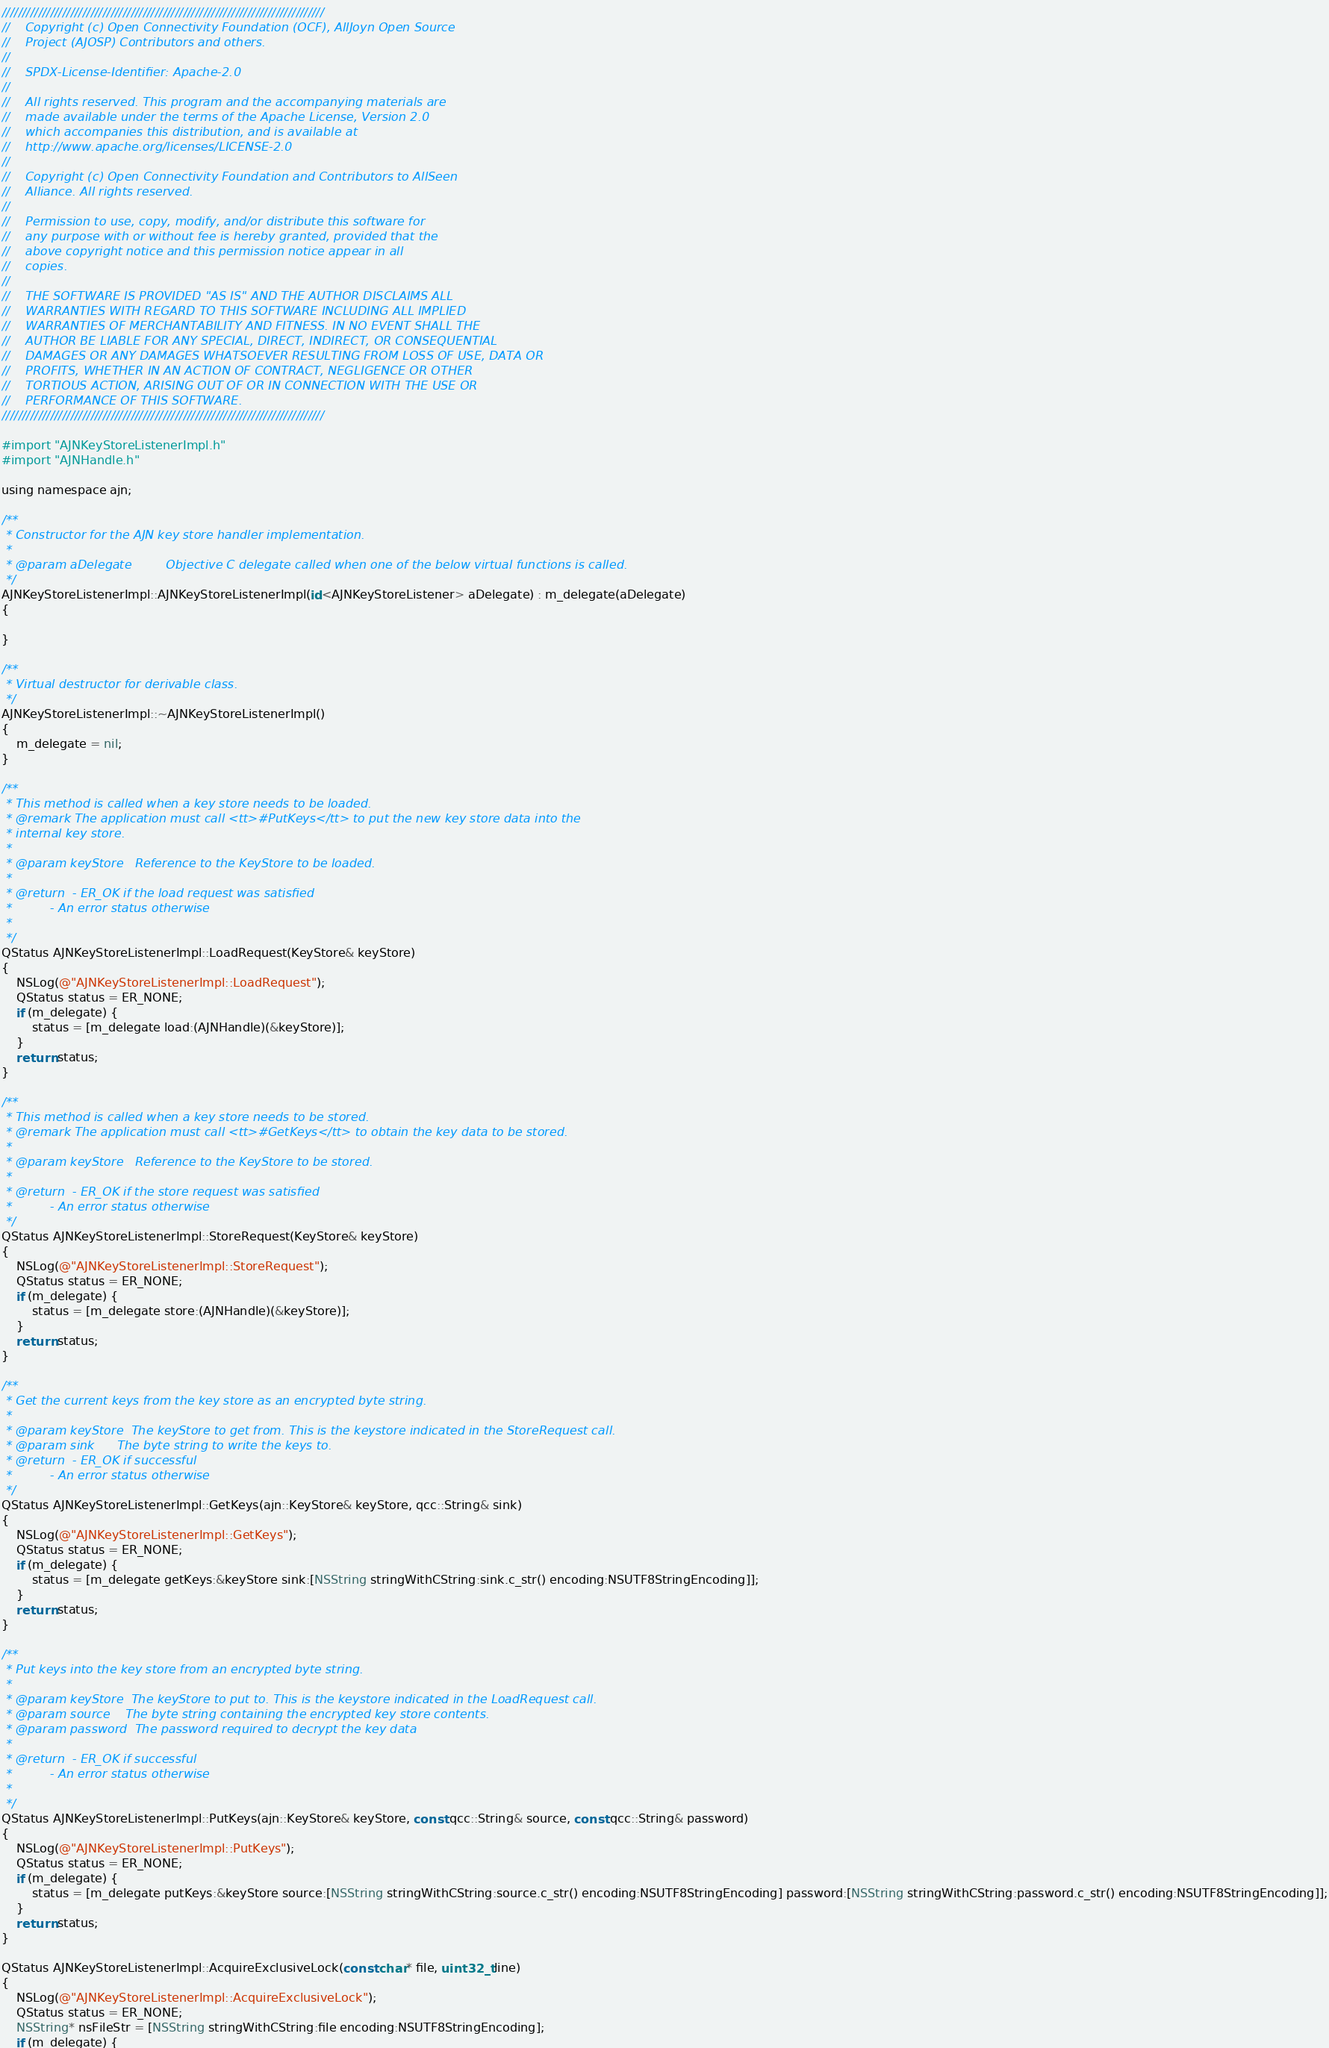Convert code to text. <code><loc_0><loc_0><loc_500><loc_500><_ObjectiveC_>////////////////////////////////////////////////////////////////////////////////
//    Copyright (c) Open Connectivity Foundation (OCF), AllJoyn Open Source
//    Project (AJOSP) Contributors and others.
//
//    SPDX-License-Identifier: Apache-2.0
//
//    All rights reserved. This program and the accompanying materials are
//    made available under the terms of the Apache License, Version 2.0
//    which accompanies this distribution, and is available at
//    http://www.apache.org/licenses/LICENSE-2.0
//
//    Copyright (c) Open Connectivity Foundation and Contributors to AllSeen
//    Alliance. All rights reserved.
//
//    Permission to use, copy, modify, and/or distribute this software for
//    any purpose with or without fee is hereby granted, provided that the
//    above copyright notice and this permission notice appear in all
//    copies.
//
//    THE SOFTWARE IS PROVIDED "AS IS" AND THE AUTHOR DISCLAIMS ALL
//    WARRANTIES WITH REGARD TO THIS SOFTWARE INCLUDING ALL IMPLIED
//    WARRANTIES OF MERCHANTABILITY AND FITNESS. IN NO EVENT SHALL THE
//    AUTHOR BE LIABLE FOR ANY SPECIAL, DIRECT, INDIRECT, OR CONSEQUENTIAL
//    DAMAGES OR ANY DAMAGES WHATSOEVER RESULTING FROM LOSS OF USE, DATA OR
//    PROFITS, WHETHER IN AN ACTION OF CONTRACT, NEGLIGENCE OR OTHER
//    TORTIOUS ACTION, ARISING OUT OF OR IN CONNECTION WITH THE USE OR
//    PERFORMANCE OF THIS SOFTWARE.
////////////////////////////////////////////////////////////////////////////////

#import "AJNKeyStoreListenerImpl.h"
#import "AJNHandle.h"

using namespace ajn;

/**
 * Constructor for the AJN key store handler implementation.
 *
 * @param aDelegate         Objective C delegate called when one of the below virtual functions is called.
 */
AJNKeyStoreListenerImpl::AJNKeyStoreListenerImpl(id<AJNKeyStoreListener> aDelegate) : m_delegate(aDelegate)
{

}

/**
 * Virtual destructor for derivable class.
 */
AJNKeyStoreListenerImpl::~AJNKeyStoreListenerImpl()
{
    m_delegate = nil;
}

/**
 * This method is called when a key store needs to be loaded.
 * @remark The application must call <tt>#PutKeys</tt> to put the new key store data into the
 * internal key store.
 *
 * @param keyStore   Reference to the KeyStore to be loaded.
 *
 * @return  - ER_OK if the load request was satisfied
 *          - An error status otherwise
 *
 */
QStatus AJNKeyStoreListenerImpl::LoadRequest(KeyStore& keyStore)
{
    NSLog(@"AJNKeyStoreListenerImpl::LoadRequest");
    QStatus status = ER_NONE;
    if (m_delegate) {
        status = [m_delegate load:(AJNHandle)(&keyStore)];
    }
    return status;
}

/**
 * This method is called when a key store needs to be stored.
 * @remark The application must call <tt>#GetKeys</tt> to obtain the key data to be stored.
 *
 * @param keyStore   Reference to the KeyStore to be stored.
 *
 * @return  - ER_OK if the store request was satisfied
 *          - An error status otherwise
 */
QStatus AJNKeyStoreListenerImpl::StoreRequest(KeyStore& keyStore)
{
    NSLog(@"AJNKeyStoreListenerImpl::StoreRequest");
    QStatus status = ER_NONE;
    if (m_delegate) {
        status = [m_delegate store:(AJNHandle)(&keyStore)];
    }
    return status;
}

/**
 * Get the current keys from the key store as an encrypted byte string.
 *
 * @param keyStore  The keyStore to get from. This is the keystore indicated in the StoreRequest call.
 * @param sink      The byte string to write the keys to.
 * @return  - ER_OK if successful
 *          - An error status otherwise
 */
QStatus AJNKeyStoreListenerImpl::GetKeys(ajn::KeyStore& keyStore, qcc::String& sink)
{
    NSLog(@"AJNKeyStoreListenerImpl::GetKeys");
    QStatus status = ER_NONE;
    if (m_delegate) {
        status = [m_delegate getKeys:&keyStore sink:[NSString stringWithCString:sink.c_str() encoding:NSUTF8StringEncoding]];
    }
    return status;
}

/**
 * Put keys into the key store from an encrypted byte string.
 *
 * @param keyStore  The keyStore to put to. This is the keystore indicated in the LoadRequest call.
 * @param source    The byte string containing the encrypted key store contents.
 * @param password  The password required to decrypt the key data
 *
 * @return  - ER_OK if successful
 *          - An error status otherwise
 *
 */
QStatus AJNKeyStoreListenerImpl::PutKeys(ajn::KeyStore& keyStore, const qcc::String& source, const qcc::String& password)
{
    NSLog(@"AJNKeyStoreListenerImpl::PutKeys");
    QStatus status = ER_NONE;
    if (m_delegate) {
        status = [m_delegate putKeys:&keyStore source:[NSString stringWithCString:source.c_str() encoding:NSUTF8StringEncoding] password:[NSString stringWithCString:password.c_str() encoding:NSUTF8StringEncoding]];
    }
    return status;
}

QStatus AJNKeyStoreListenerImpl::AcquireExclusiveLock(const char* file, uint32_t line)
{
    NSLog(@"AJNKeyStoreListenerImpl::AcquireExclusiveLock");
    QStatus status = ER_NONE;
    NSString* nsFileStr = [NSString stringWithCString:file encoding:NSUTF8StringEncoding];
    if (m_delegate) {</code> 